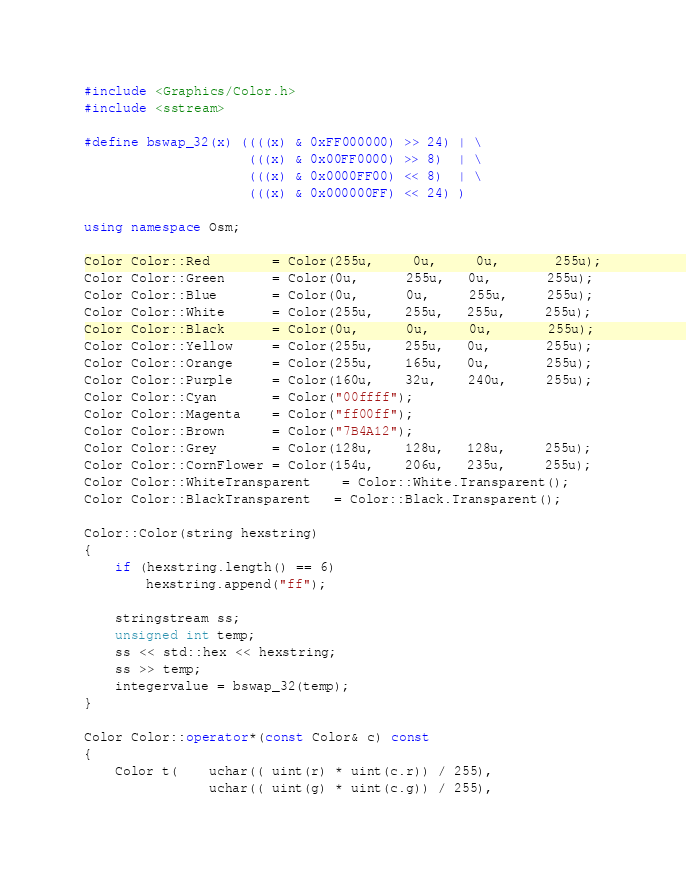Convert code to text. <code><loc_0><loc_0><loc_500><loc_500><_C++_>#include <Graphics/Color.h>
#include <sstream>

#define bswap_32(x) ((((x) & 0xFF000000) >> 24) | \
                     (((x) & 0x00FF0000) >> 8)  | \
                     (((x) & 0x0000FF00) << 8)  | \
                     (((x) & 0x000000FF) << 24) )

using namespace Osm;

Color Color::Red        = Color(255u,	 0u,	 0u,	   255u);
Color Color::Green      = Color(0u,      255u,   0u,       255u);
Color Color::Blue       = Color(0u,      0u,     255u,     255u);
Color Color::White      = Color(255u,    255u,   255u,     255u);
Color Color::Black      = Color(0u,      0u,     0u,       255u);
Color Color::Yellow     = Color(255u,    255u,   0u,       255u);
Color Color::Orange     = Color(255u,    165u,   0u,       255u);
Color Color::Purple     = Color(160u,    32u,    240u,     255u);
Color Color::Cyan       = Color("00ffff");
Color Color::Magenta    = Color("ff00ff");
Color Color::Brown      = Color("7B4A12");
Color Color::Grey       = Color(128u,    128u,   128u,     255u);
Color Color::CornFlower = Color(154u,    206u,   235u,     255u);
Color Color::WhiteTransparent	= Color::White.Transparent();
Color Color::BlackTransparent   = Color::Black.Transparent();

Color::Color(string hexstring)
{
    if (hexstring.length() == 6)
        hexstring.append("ff");
    
    stringstream ss;
    unsigned int temp;
    ss << std::hex << hexstring;
    ss >> temp;
    integervalue = bswap_32(temp);
}

Color Color::operator*(const Color& c) const
{
    Color t(    uchar(( uint(r) * uint(c.r)) / 255),
                uchar(( uint(g) * uint(c.g)) / 255),</code> 